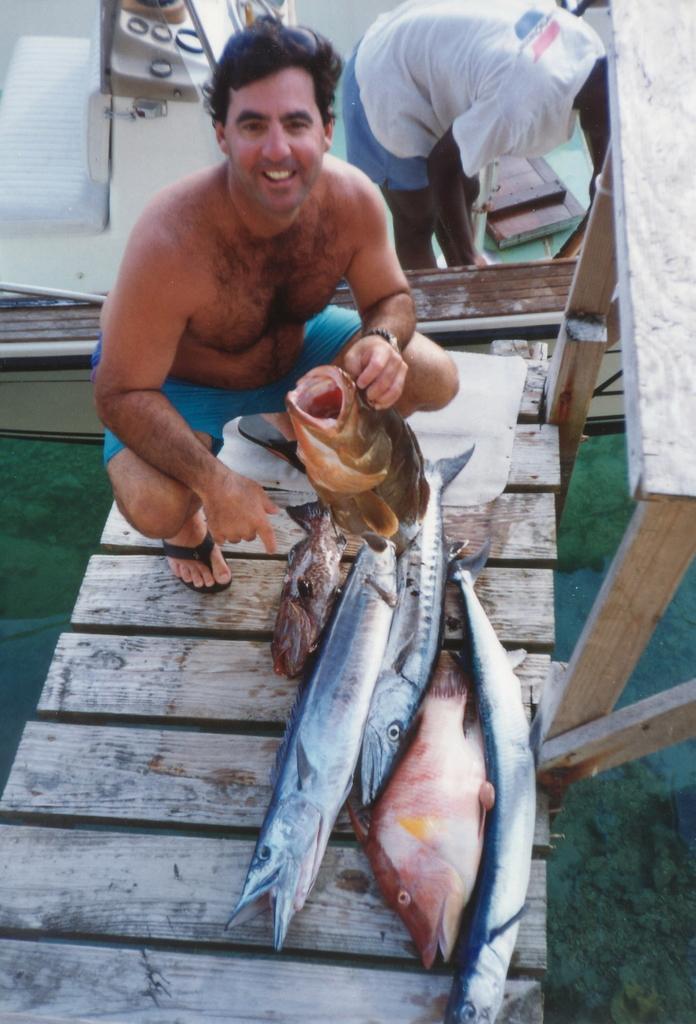How would you summarize this image in a sentence or two? In this image, we can see a person wearing clothes and holding a fish with his hand. There are fishes on the bridge. There is an another person in the top right of the image. 